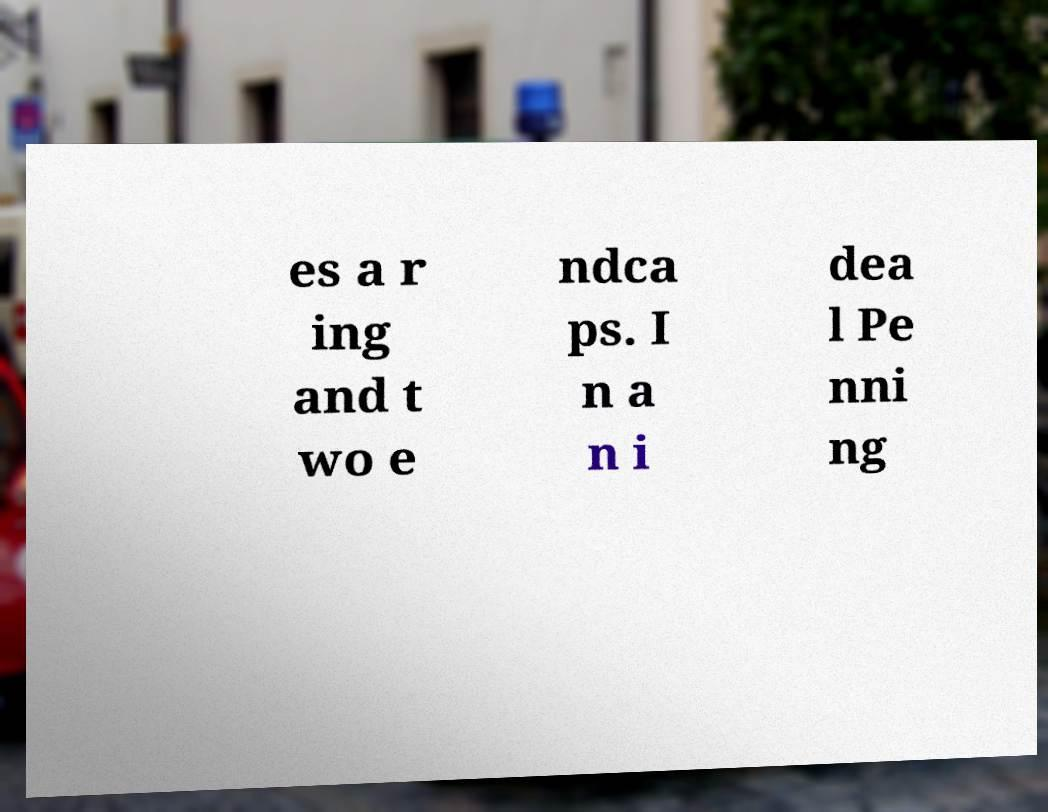Could you extract and type out the text from this image? es a r ing and t wo e ndca ps. I n a n i dea l Pe nni ng 